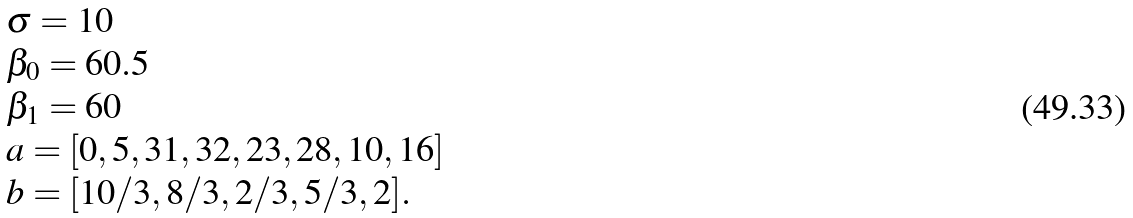Convert formula to latex. <formula><loc_0><loc_0><loc_500><loc_500>\begin{array} { l } \sigma = 1 0 \\ \beta _ { 0 } = 6 0 . 5 \\ \beta _ { 1 } = 6 0 \\ a = [ 0 , 5 , 3 1 , 3 2 , 2 3 , 2 8 , 1 0 , 1 6 ] \\ b = [ 1 0 / 3 , 8 / 3 , 2 / 3 , 5 / 3 , 2 ] . \end{array}</formula> 